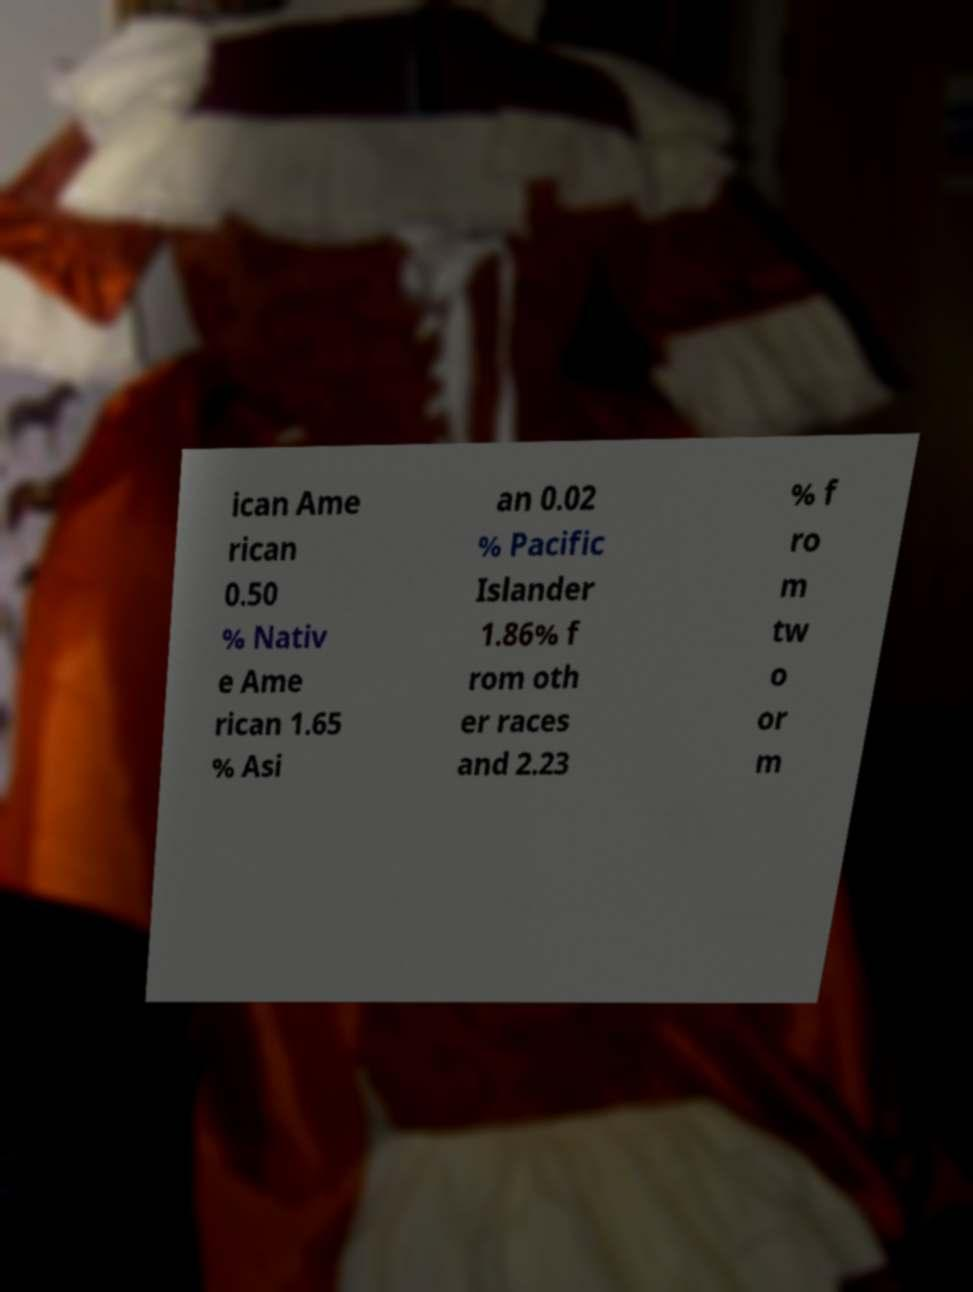For documentation purposes, I need the text within this image transcribed. Could you provide that? ican Ame rican 0.50 % Nativ e Ame rican 1.65 % Asi an 0.02 % Pacific Islander 1.86% f rom oth er races and 2.23 % f ro m tw o or m 